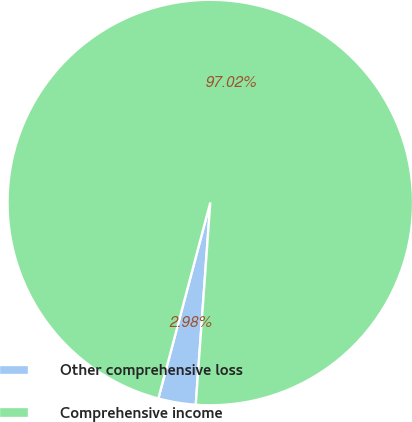<chart> <loc_0><loc_0><loc_500><loc_500><pie_chart><fcel>Other comprehensive loss<fcel>Comprehensive income<nl><fcel>2.98%<fcel>97.02%<nl></chart> 